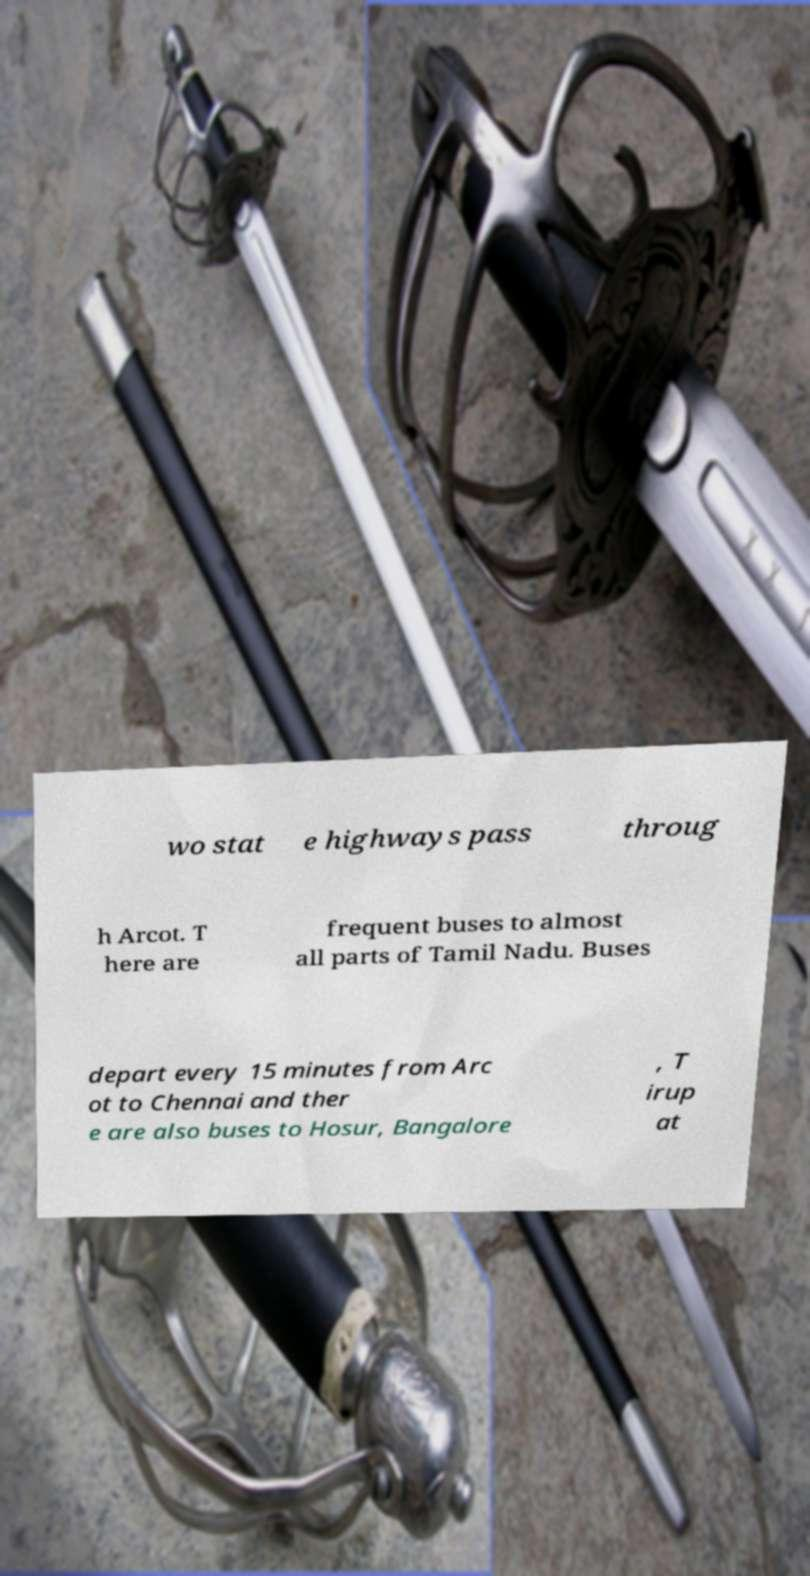Could you extract and type out the text from this image? wo stat e highways pass throug h Arcot. T here are frequent buses to almost all parts of Tamil Nadu. Buses depart every 15 minutes from Arc ot to Chennai and ther e are also buses to Hosur, Bangalore , T irup at 